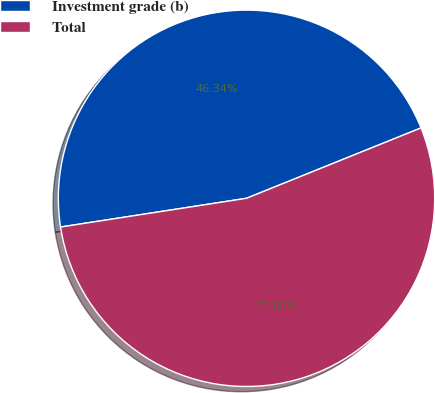Convert chart. <chart><loc_0><loc_0><loc_500><loc_500><pie_chart><fcel>Investment grade (b)<fcel>Total<nl><fcel>46.34%<fcel>53.66%<nl></chart> 